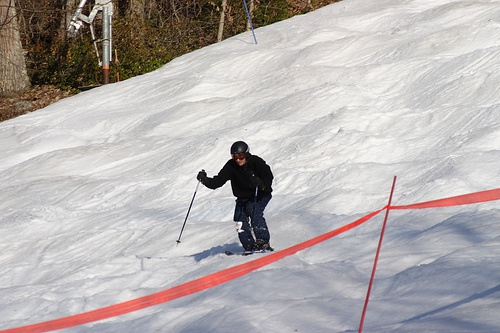Describe the objects in this image and their specific colors. I can see people in gray, black, and darkgray tones, skis in gray and black tones, and skis in gray, darkgray, blue, and navy tones in this image. 